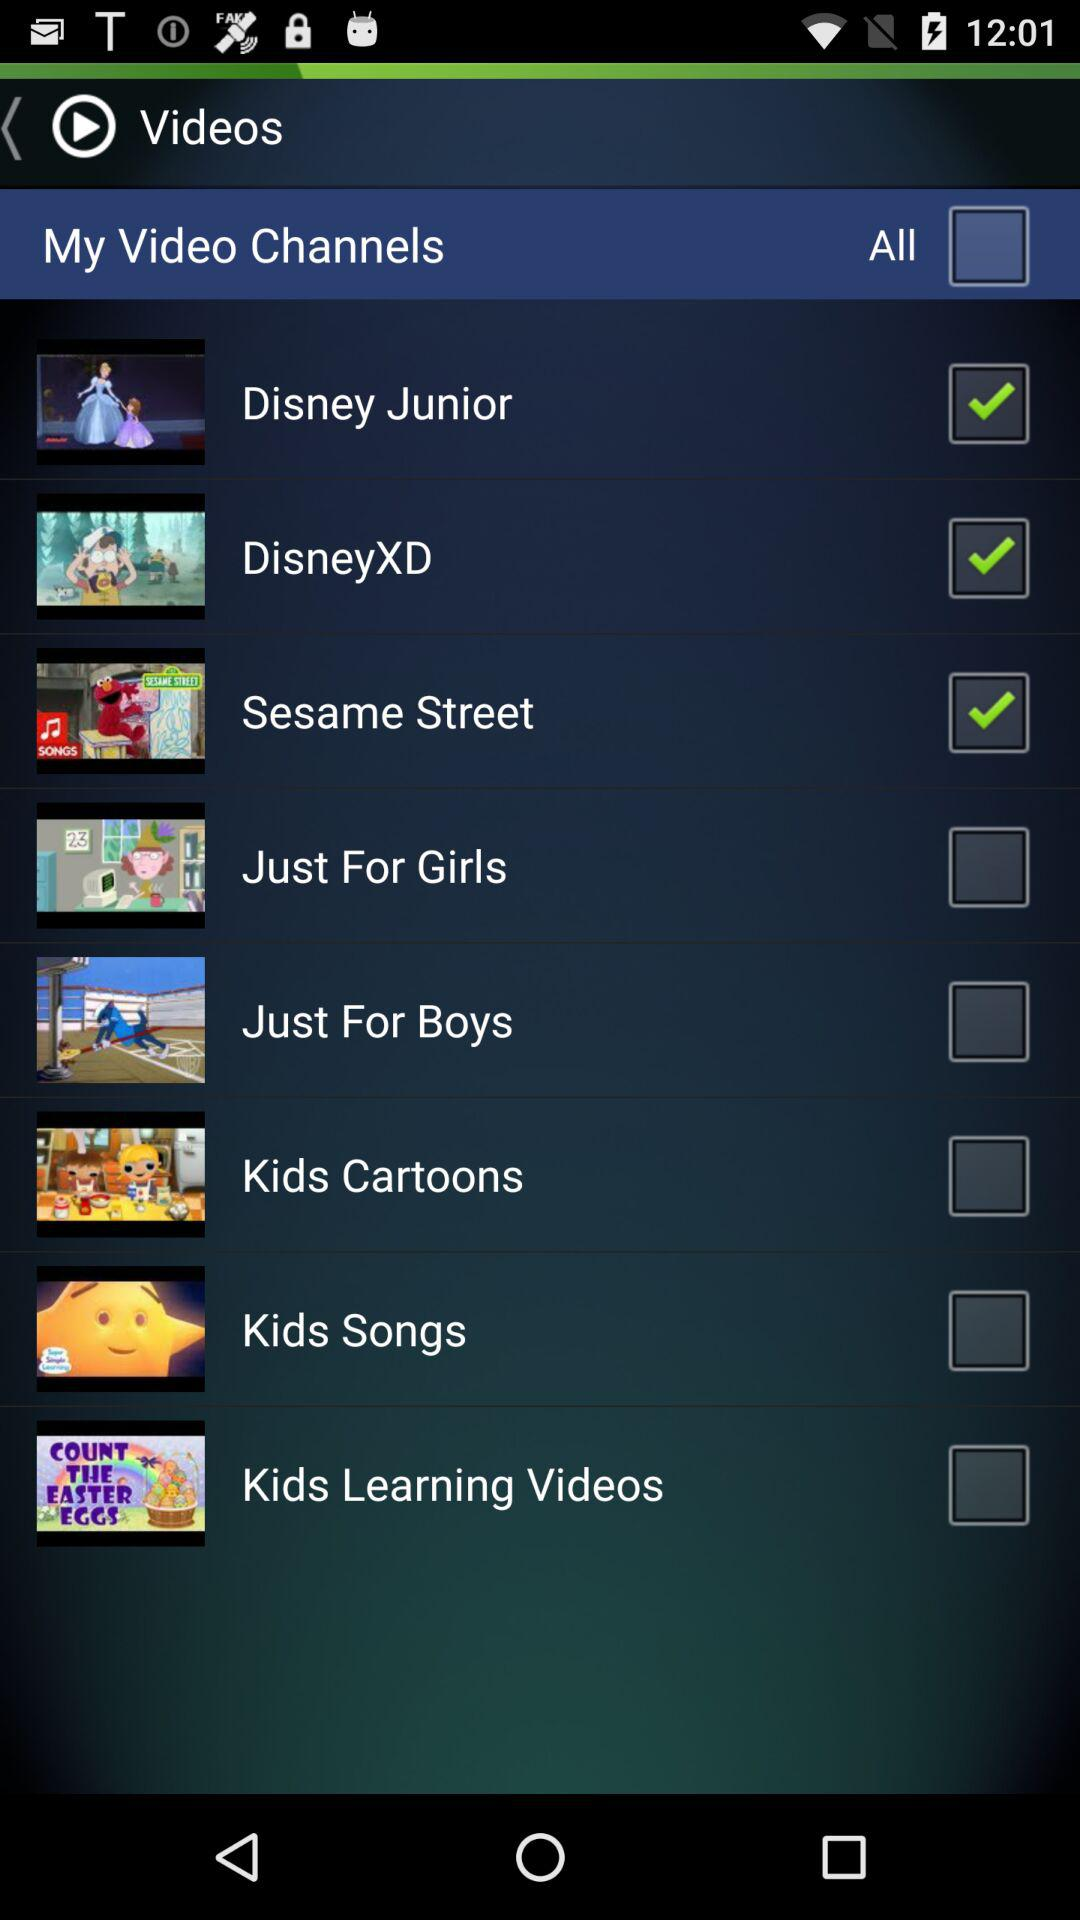Is "Disney Junior" checked or not?
Answer the question using a single word or phrase. It is "checked". 